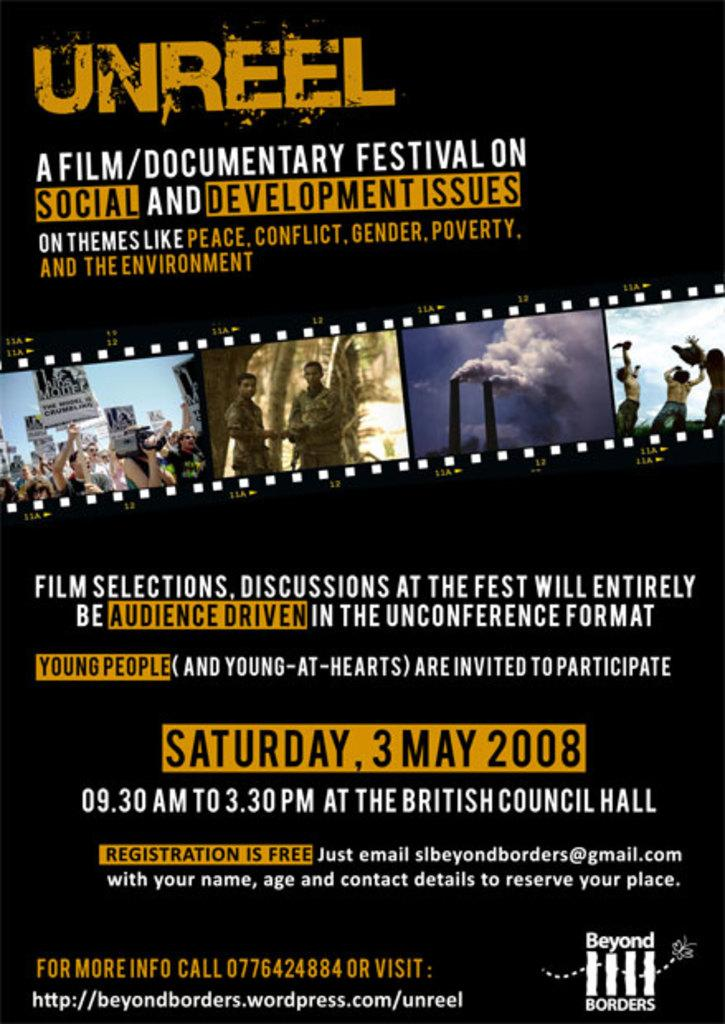<image>
Provide a brief description of the given image. A poster announcing a Film/Documentary Festival on Social and Development Issues called Unreel 